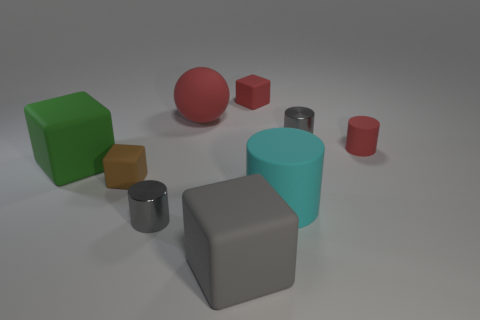Subtract 2 cylinders. How many cylinders are left? 2 Add 1 gray cubes. How many objects exist? 10 Subtract all small cylinders. How many cylinders are left? 1 Subtract all purple cubes. Subtract all gray spheres. How many cubes are left? 4 Subtract all blocks. How many objects are left? 5 Subtract all red balls. Subtract all small gray things. How many objects are left? 6 Add 5 metallic cylinders. How many metallic cylinders are left? 7 Add 9 cyan rubber objects. How many cyan rubber objects exist? 10 Subtract 1 cyan cylinders. How many objects are left? 8 